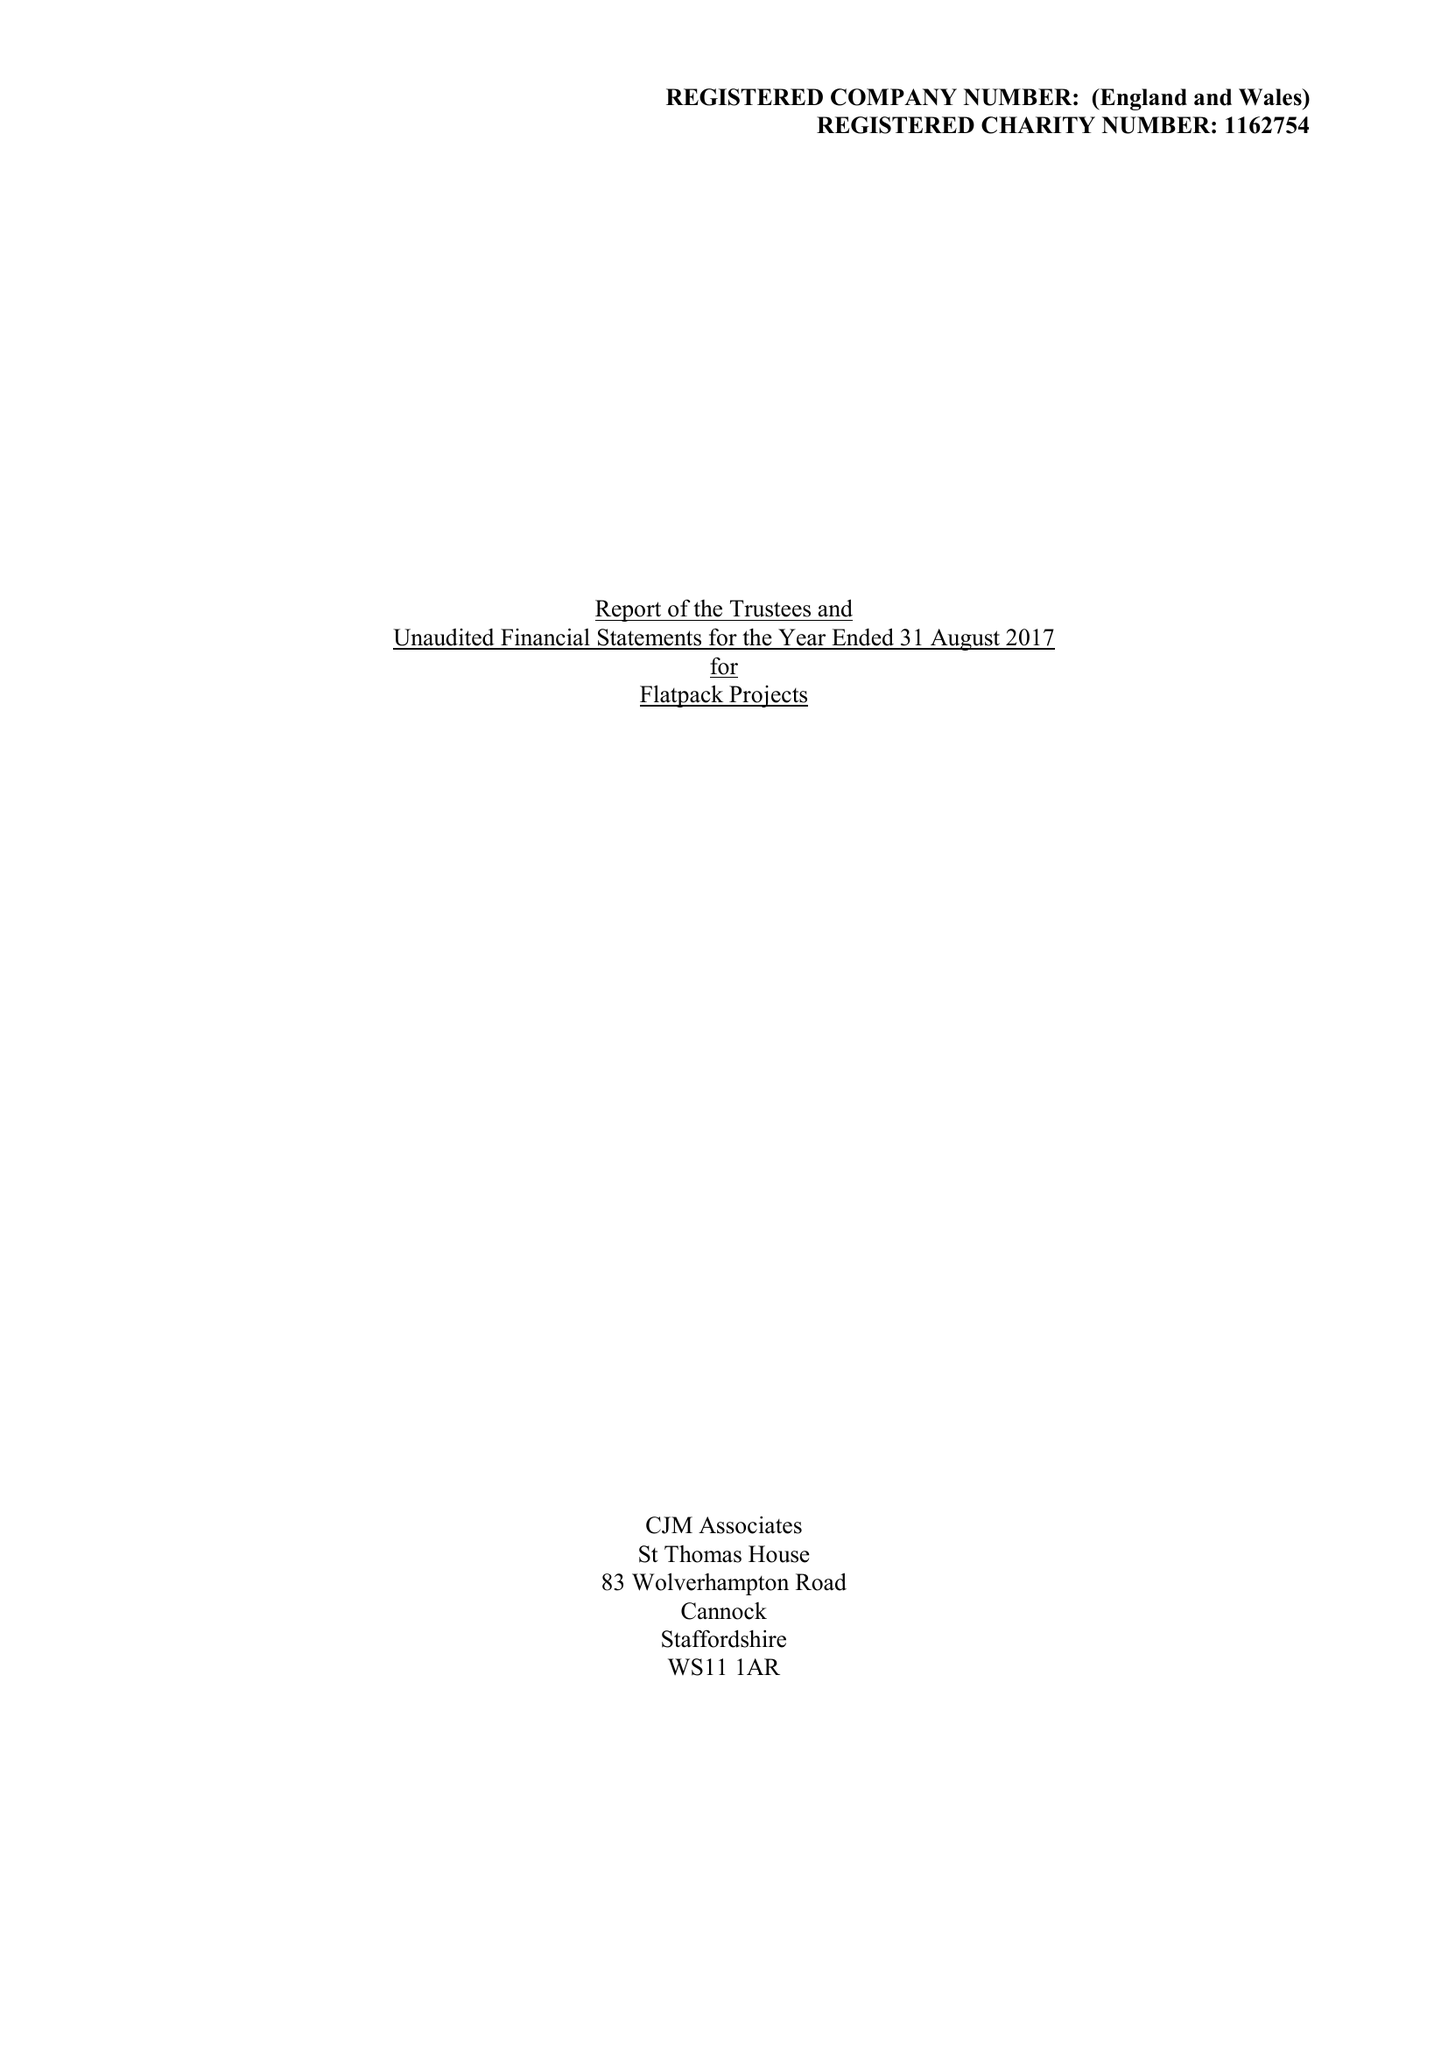What is the value for the report_date?
Answer the question using a single word or phrase. 2017-08-31 